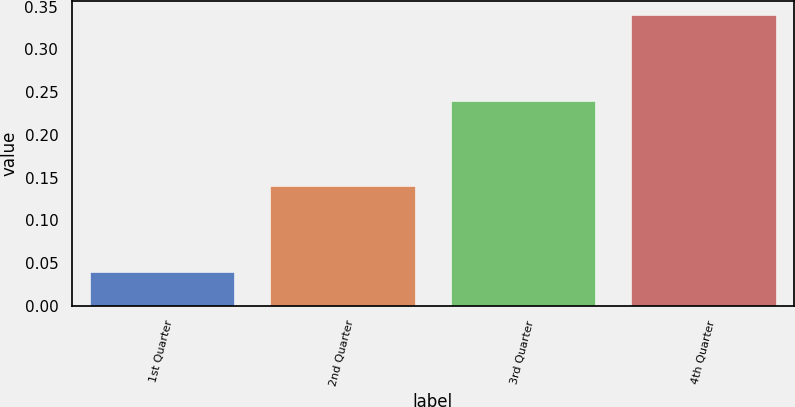Convert chart. <chart><loc_0><loc_0><loc_500><loc_500><bar_chart><fcel>1st Quarter<fcel>2nd Quarter<fcel>3rd Quarter<fcel>4th Quarter<nl><fcel>0.04<fcel>0.14<fcel>0.24<fcel>0.34<nl></chart> 